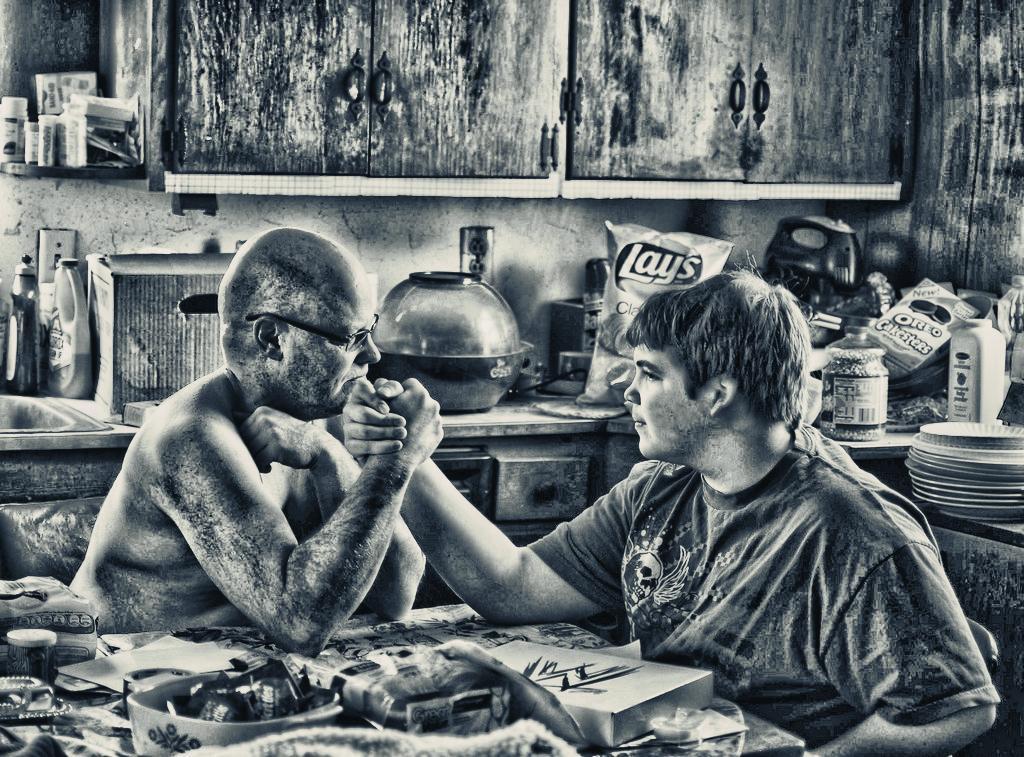Please provide a concise description of this image. In this image there are two persons at the background of the image there are some eatable items. 